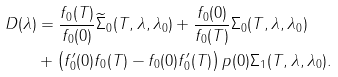Convert formula to latex. <formula><loc_0><loc_0><loc_500><loc_500>D ( \lambda ) & = \frac { f _ { 0 } ( T ) } { f _ { 0 } ( 0 ) } \widetilde { \Sigma } _ { 0 } ( T , \lambda , \lambda _ { 0 } ) + \frac { f _ { 0 } ( 0 ) } { f _ { 0 } ( T ) } \Sigma _ { 0 } ( T , \lambda , \lambda _ { 0 } ) \\ & + \left ( f _ { 0 } ^ { \prime } ( 0 ) f _ { 0 } ( T ) - f _ { 0 } ( 0 ) f _ { 0 } ^ { \prime } ( T ) \right ) p ( 0 ) \Sigma _ { 1 } ( T , \lambda , \lambda _ { 0 } ) .</formula> 